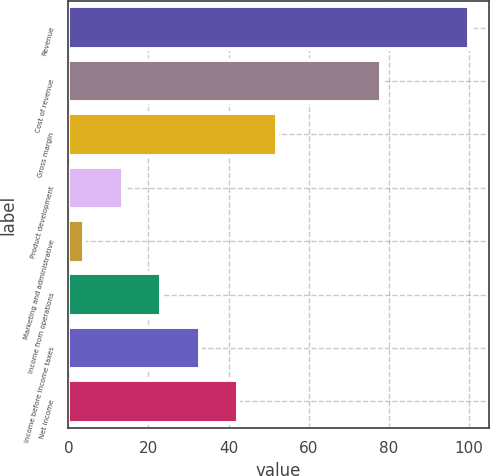Convert chart. <chart><loc_0><loc_0><loc_500><loc_500><bar_chart><fcel>Revenue<fcel>Cost of revenue<fcel>Gross margin<fcel>Product development<fcel>Marketing and administrative<fcel>Income from operations<fcel>Income before income taxes<fcel>Net income<nl><fcel>100<fcel>78<fcel>52<fcel>13.6<fcel>4<fcel>23.2<fcel>32.8<fcel>42.4<nl></chart> 